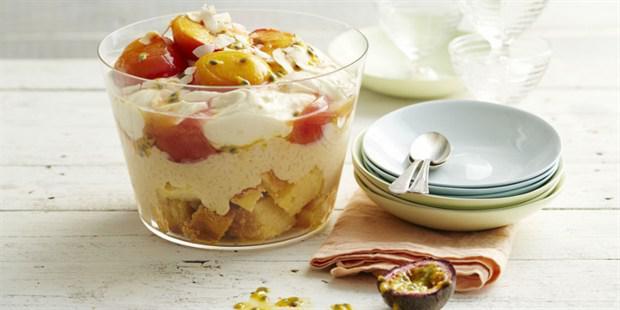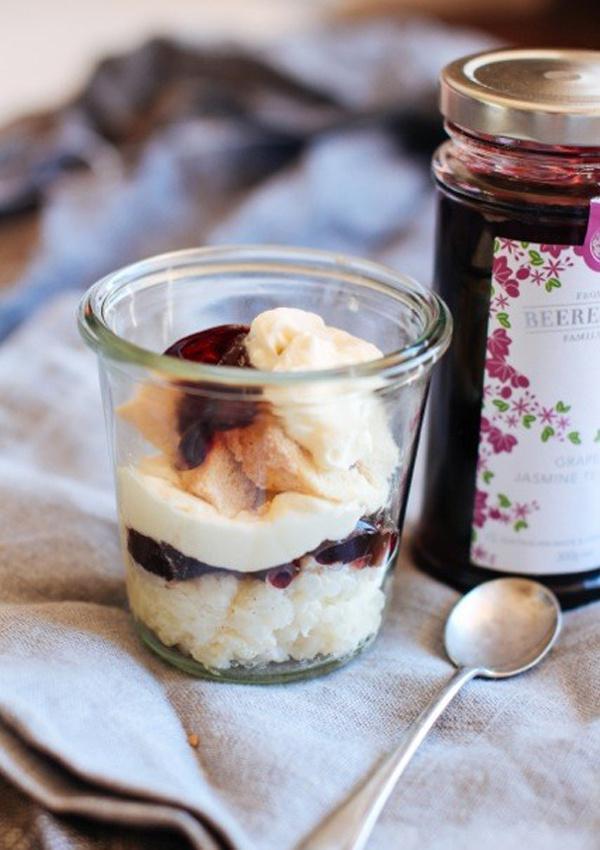The first image is the image on the left, the second image is the image on the right. For the images shown, is this caption "There is white flatware with a ribbon tied around it." true? Answer yes or no. No. 